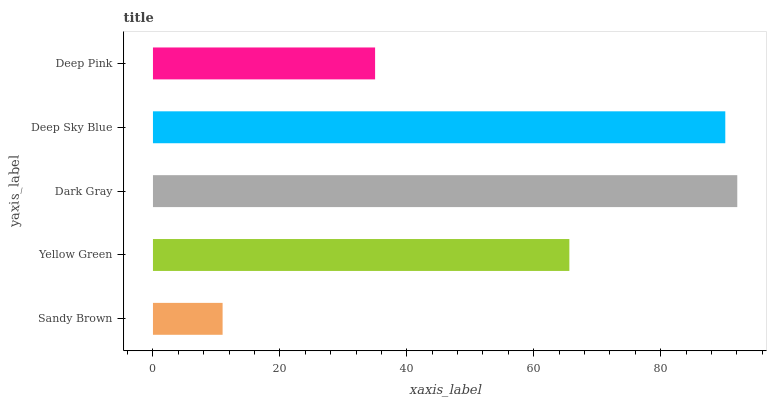Is Sandy Brown the minimum?
Answer yes or no. Yes. Is Dark Gray the maximum?
Answer yes or no. Yes. Is Yellow Green the minimum?
Answer yes or no. No. Is Yellow Green the maximum?
Answer yes or no. No. Is Yellow Green greater than Sandy Brown?
Answer yes or no. Yes. Is Sandy Brown less than Yellow Green?
Answer yes or no. Yes. Is Sandy Brown greater than Yellow Green?
Answer yes or no. No. Is Yellow Green less than Sandy Brown?
Answer yes or no. No. Is Yellow Green the high median?
Answer yes or no. Yes. Is Yellow Green the low median?
Answer yes or no. Yes. Is Sandy Brown the high median?
Answer yes or no. No. Is Sandy Brown the low median?
Answer yes or no. No. 